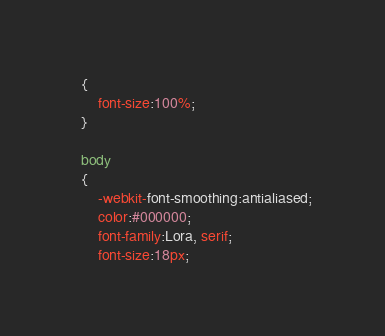<code> <loc_0><loc_0><loc_500><loc_500><_CSS_>  {
      font-size:100%;
  }
  
  body
  {
      -webkit-font-smoothing:antialiased;
      color:#000000;
      font-family:Lora, serif;
      font-size:18px;</code> 